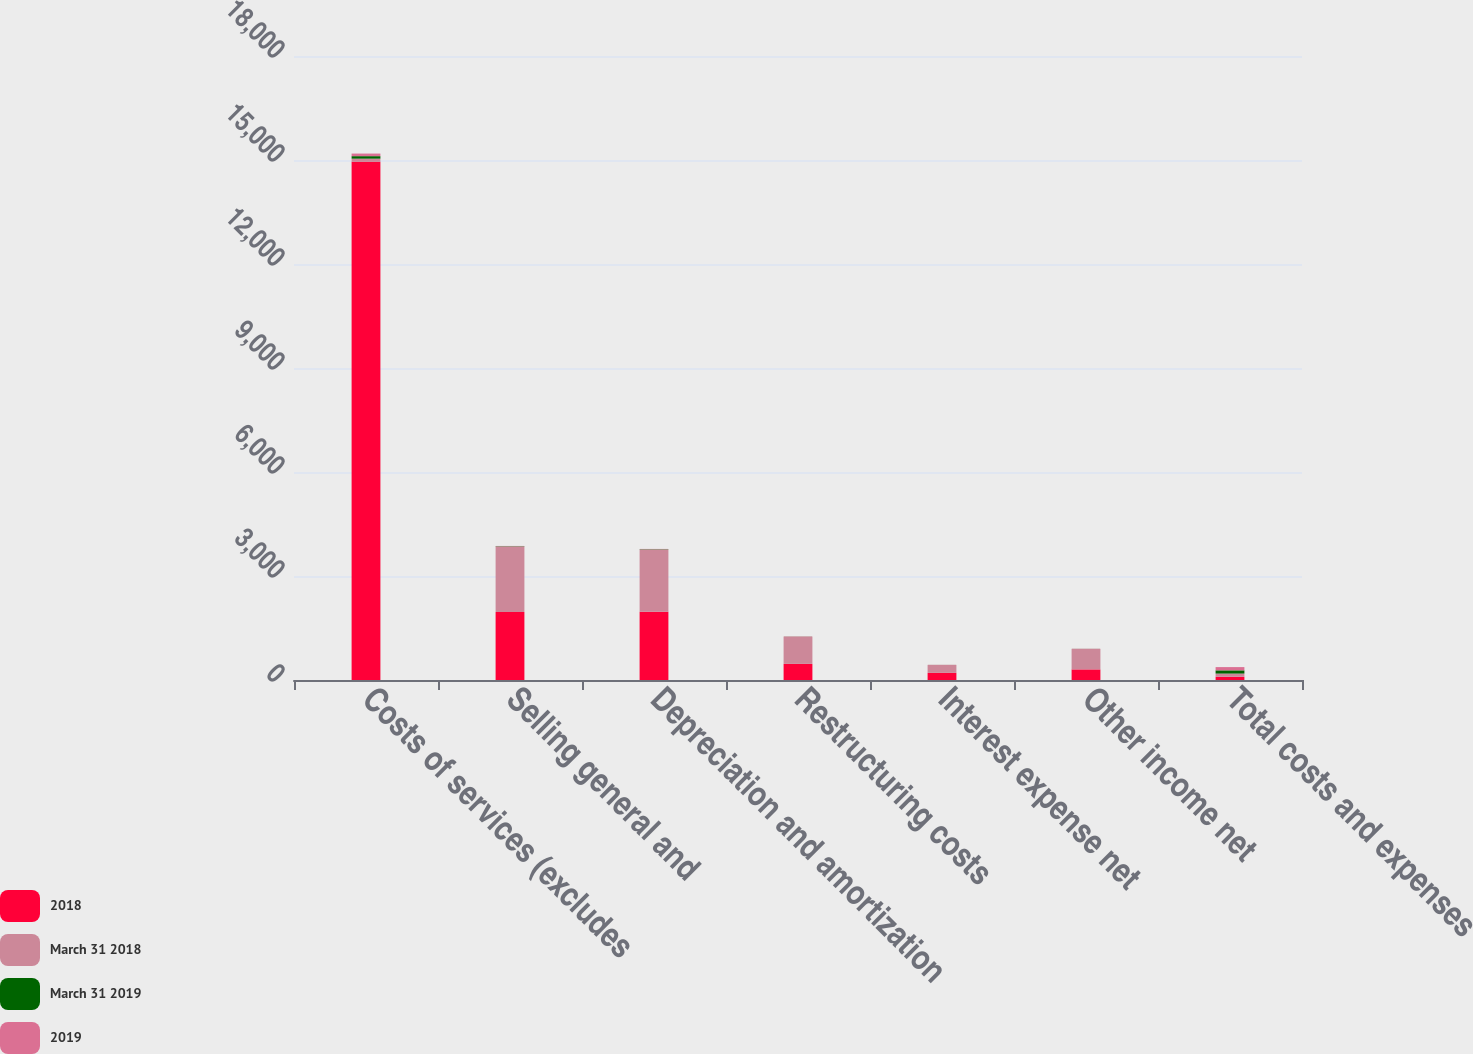<chart> <loc_0><loc_0><loc_500><loc_500><stacked_bar_chart><ecel><fcel>Costs of services (excludes<fcel>Selling general and<fcel>Depreciation and amortization<fcel>Restructuring costs<fcel>Interest expense net<fcel>Other income net<fcel>Total costs and expenses<nl><fcel>2018<fcel>14946<fcel>1959<fcel>1968<fcel>465<fcel>206<fcel>306<fcel>92.7<nl><fcel>March 31 2018<fcel>92.7<fcel>1890<fcel>1795<fcel>789<fcel>231<fcel>593<fcel>92.7<nl><fcel>March 31 2019<fcel>72.1<fcel>9.4<fcel>9.5<fcel>2.2<fcel>1<fcel>1.5<fcel>92.7<nl><fcel>2019<fcel>75<fcel>8.7<fcel>8.3<fcel>3.6<fcel>1.1<fcel>2.7<fcel>94<nl></chart> 